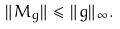<formula> <loc_0><loc_0><loc_500><loc_500>\| M _ { g } \| \leq \| g \| _ { \infty } .</formula> 